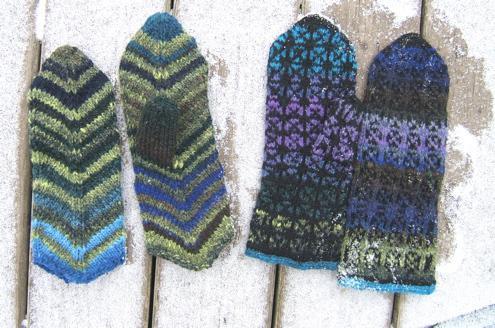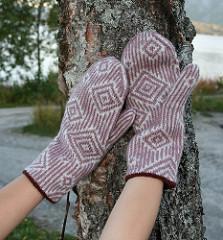The first image is the image on the left, the second image is the image on the right. Given the left and right images, does the statement "An image shows a pair of mittens featuring a pattern of vertical stripes and concentric diamonds." hold true? Answer yes or no. Yes. The first image is the image on the left, the second image is the image on the right. For the images displayed, is the sentence "Only one mitten is shown in the image on the left." factually correct? Answer yes or no. No. 